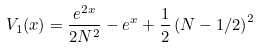Convert formula to latex. <formula><loc_0><loc_0><loc_500><loc_500>V _ { 1 } ( x ) = \frac { e ^ { 2 x } } { 2 N ^ { 2 } } - e ^ { x } + \frac { 1 } { 2 } \left ( N - 1 / 2 \right ) ^ { 2 }</formula> 